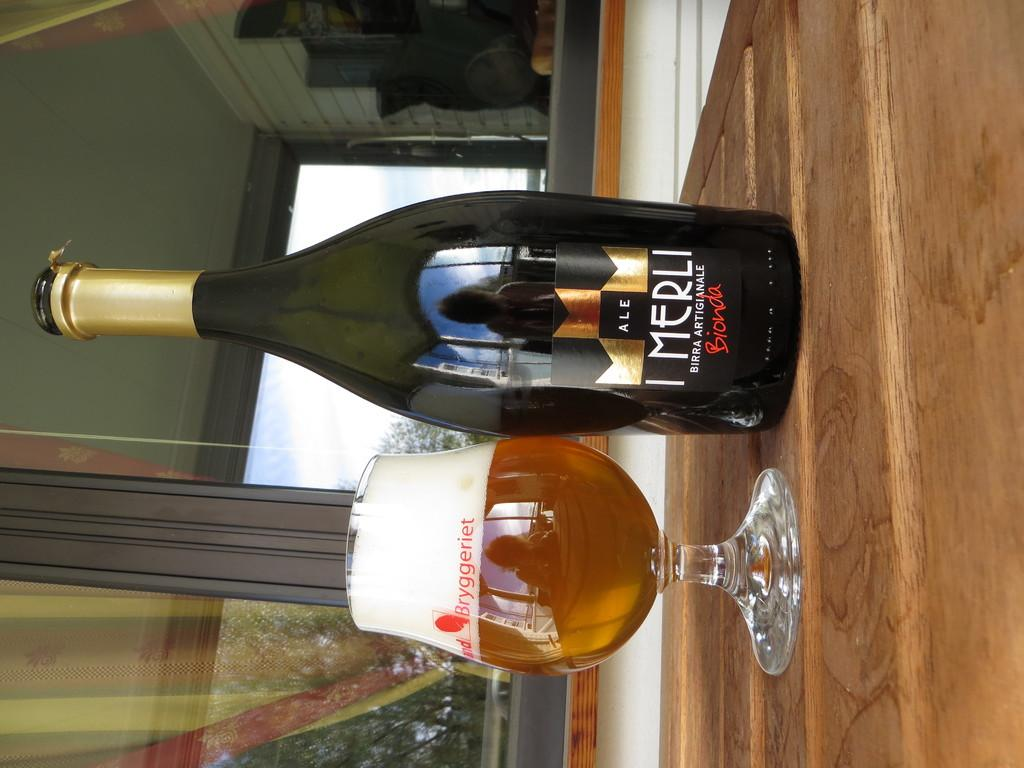<image>
Write a terse but informative summary of the picture. Bottle of ale that says the word "MERLI" on it in white. 